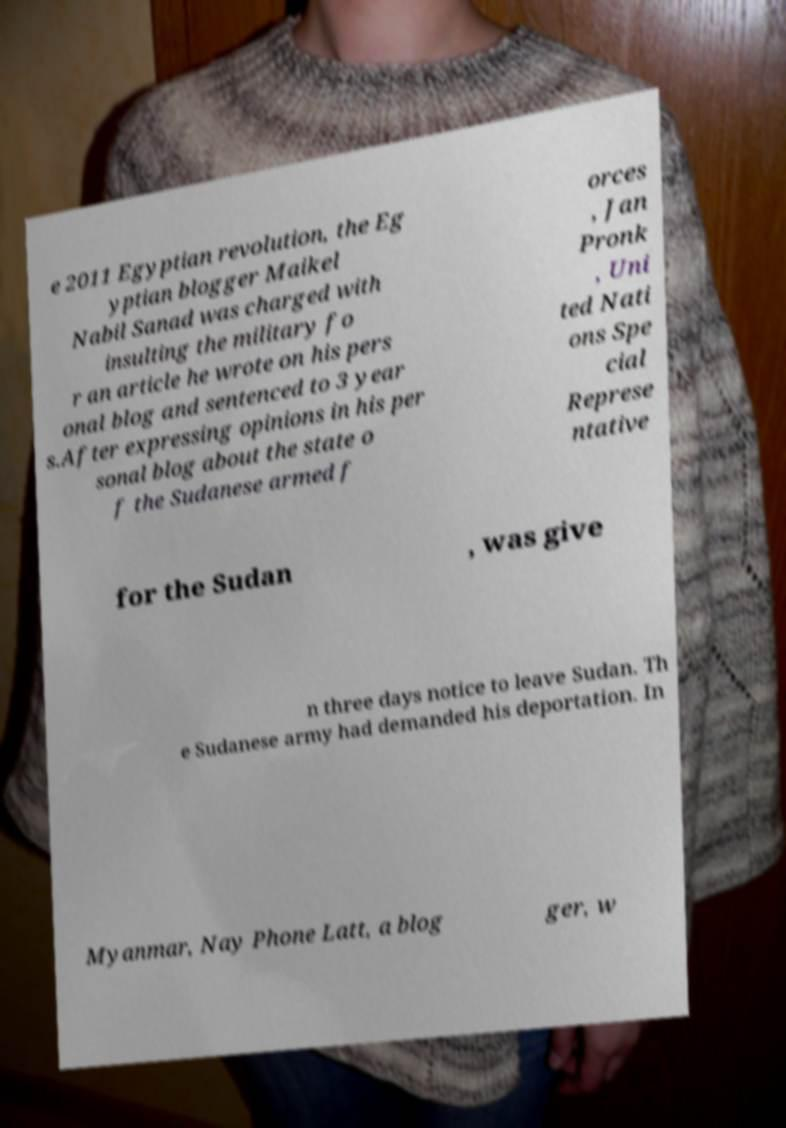Please identify and transcribe the text found in this image. e 2011 Egyptian revolution, the Eg yptian blogger Maikel Nabil Sanad was charged with insulting the military fo r an article he wrote on his pers onal blog and sentenced to 3 year s.After expressing opinions in his per sonal blog about the state o f the Sudanese armed f orces , Jan Pronk , Uni ted Nati ons Spe cial Represe ntative for the Sudan , was give n three days notice to leave Sudan. Th e Sudanese army had demanded his deportation. In Myanmar, Nay Phone Latt, a blog ger, w 